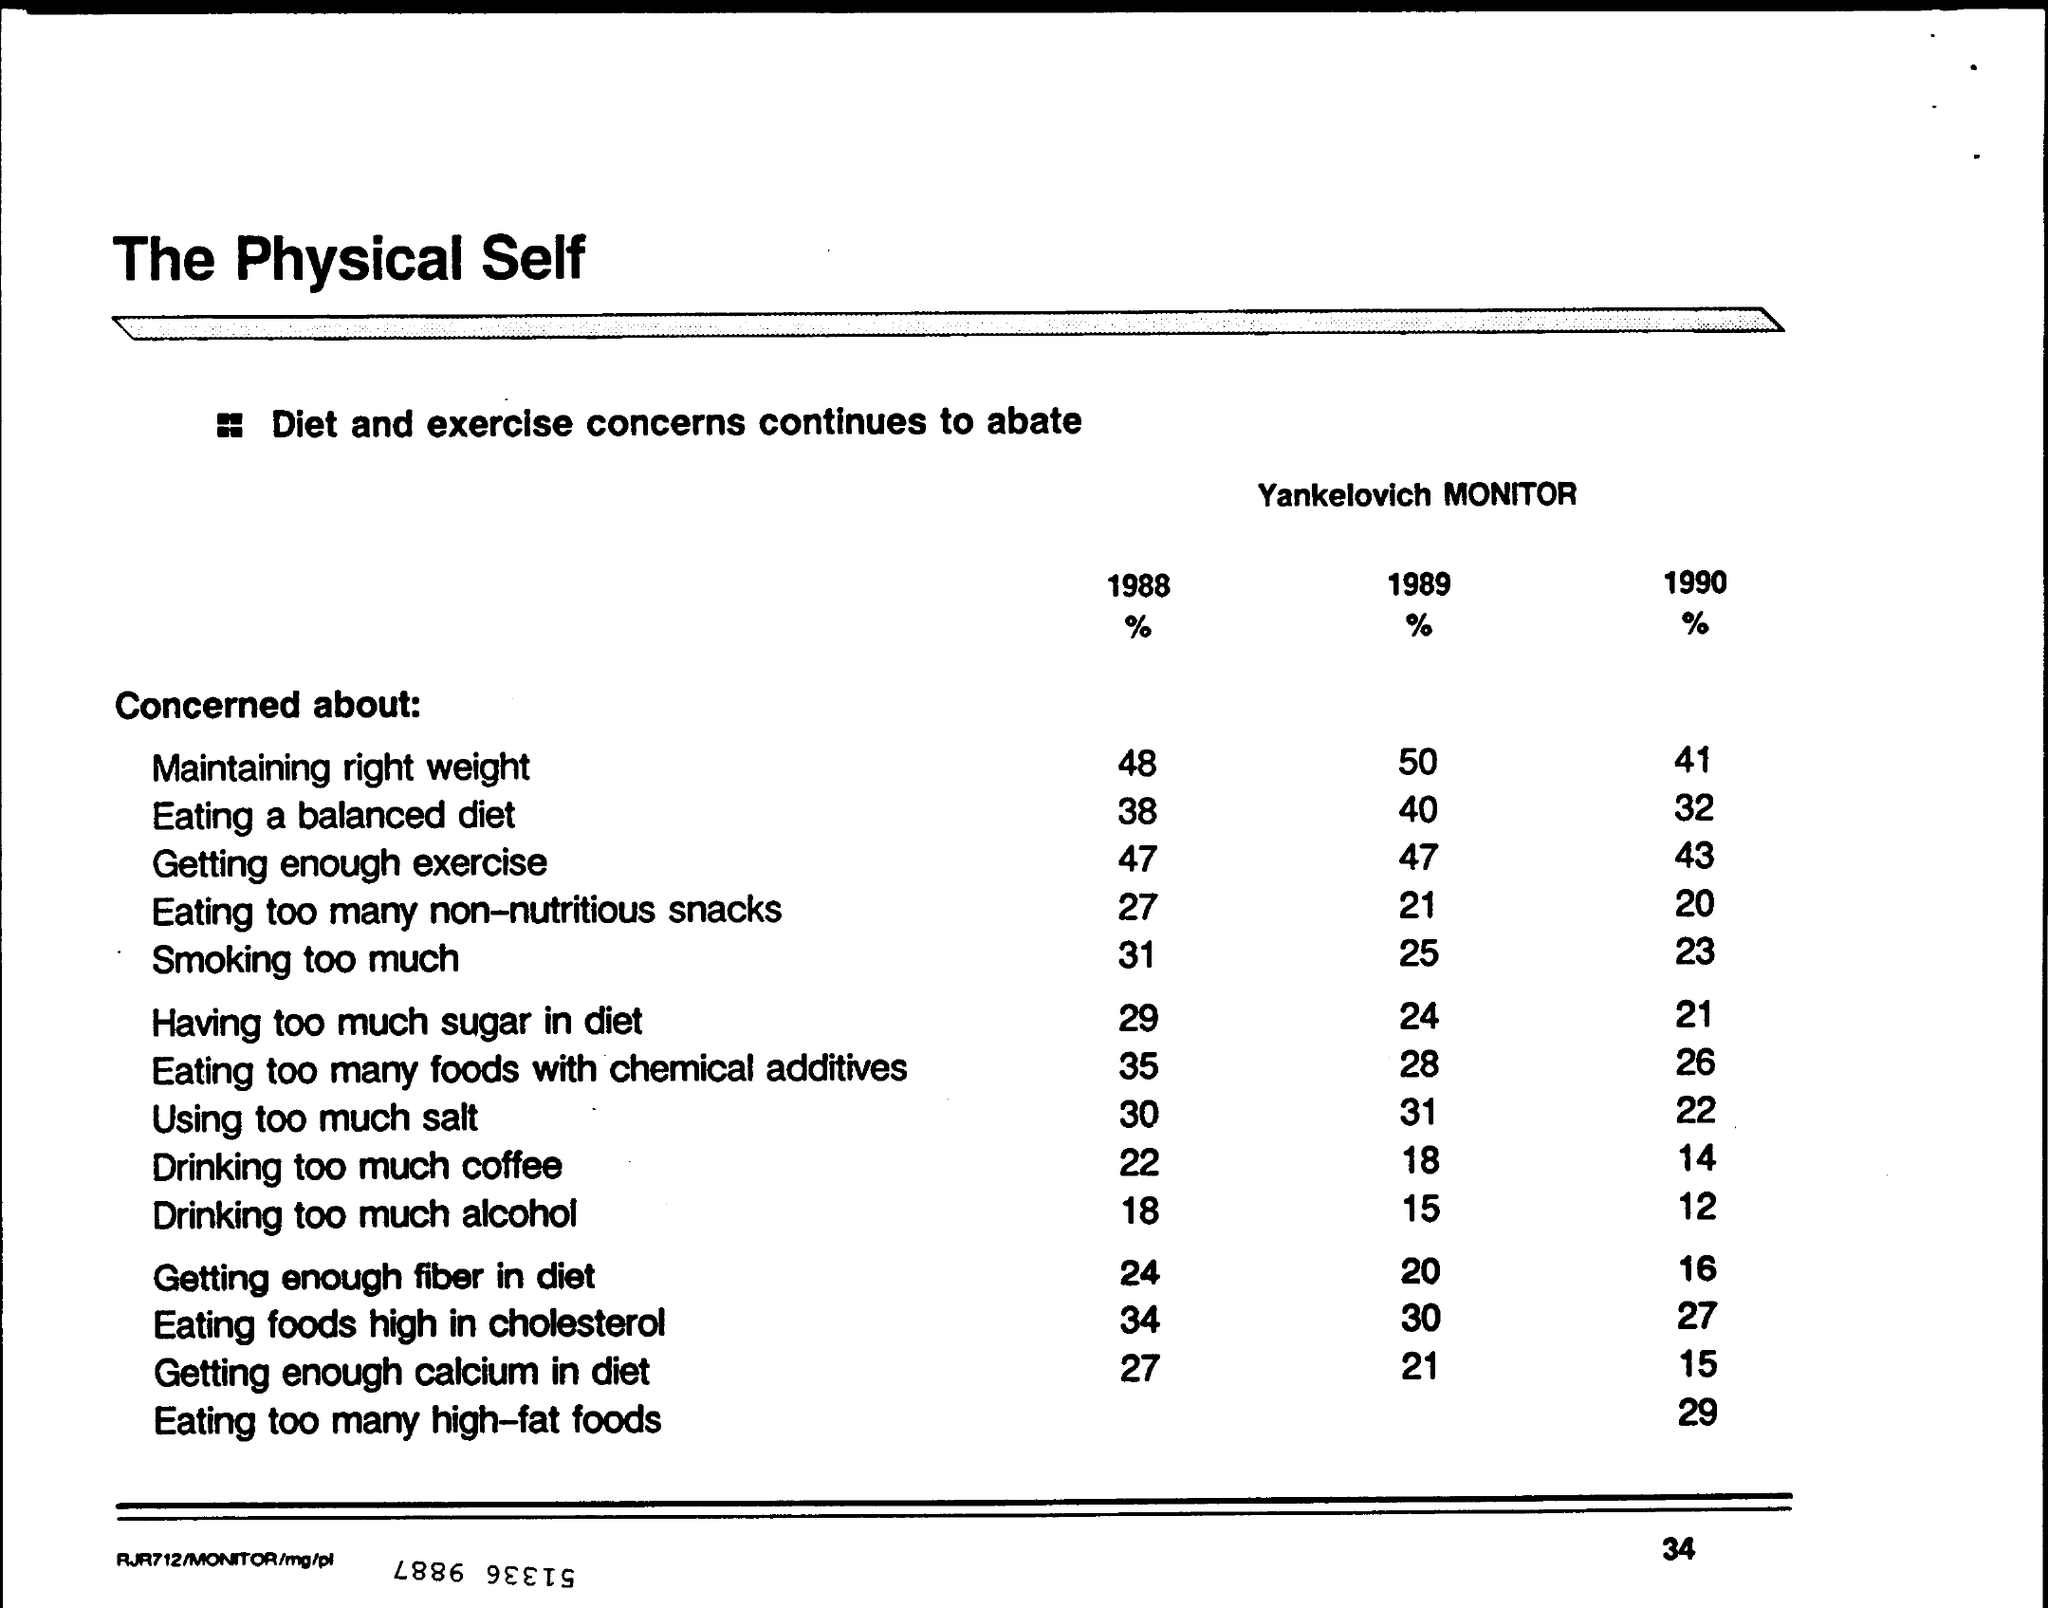Outline some significant characteristics in this image. In 1989, it was found that 31% of people were concerned about using too much salt. In 1989, it was found that a significant percentage of people were concerned about drinking too much alcohol. In 1989, it was found that 50% of individuals were concerned about maintaining the right weight. In 1988, 48% of people were concerned about maintaining the right weight. In 1990, approximately 41% of individuals were concerned about maintaining the right weight. 